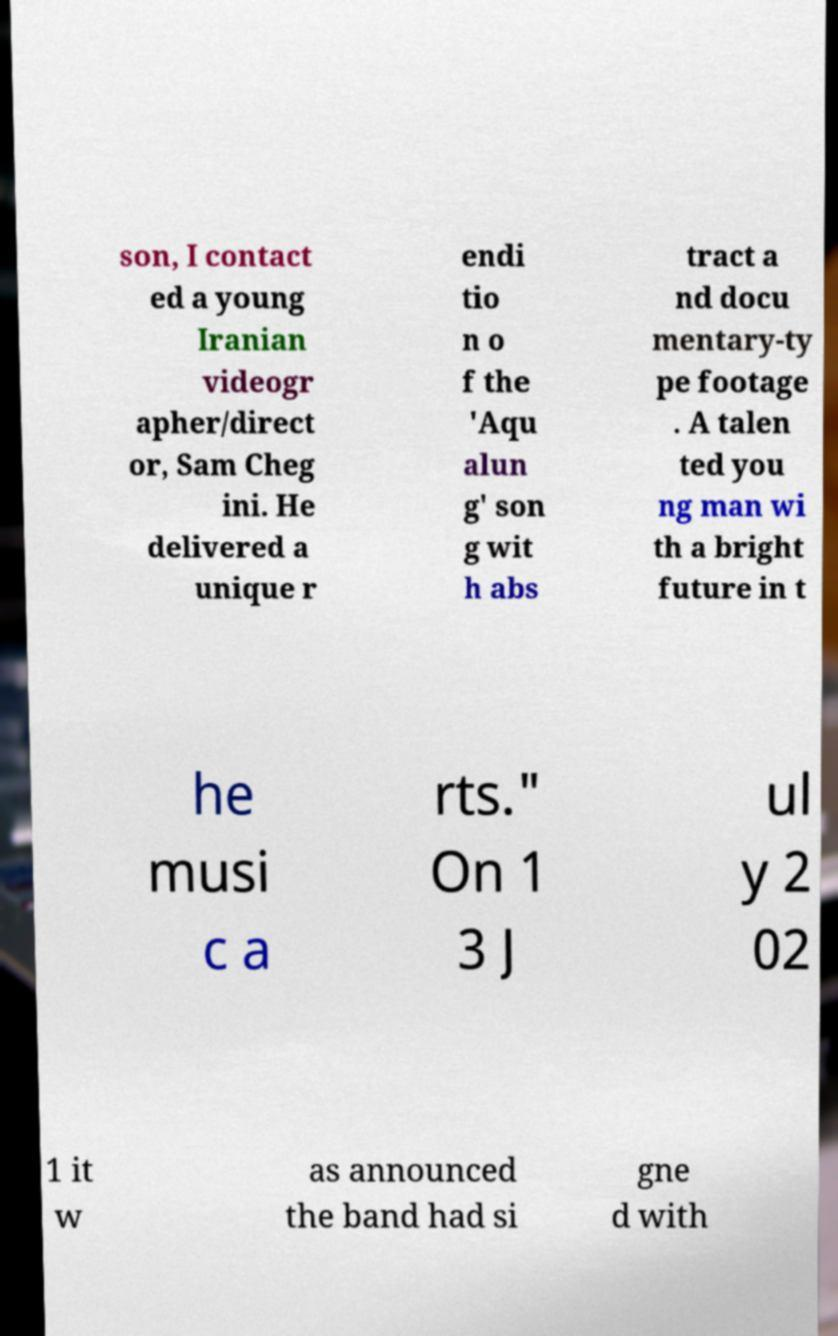Please read and relay the text visible in this image. What does it say? son, I contact ed a young Iranian videogr apher/direct or, Sam Cheg ini. He delivered a unique r endi tio n o f the 'Aqu alun g' son g wit h abs tract a nd docu mentary-ty pe footage . A talen ted you ng man wi th a bright future in t he musi c a rts." On 1 3 J ul y 2 02 1 it w as announced the band had si gne d with 